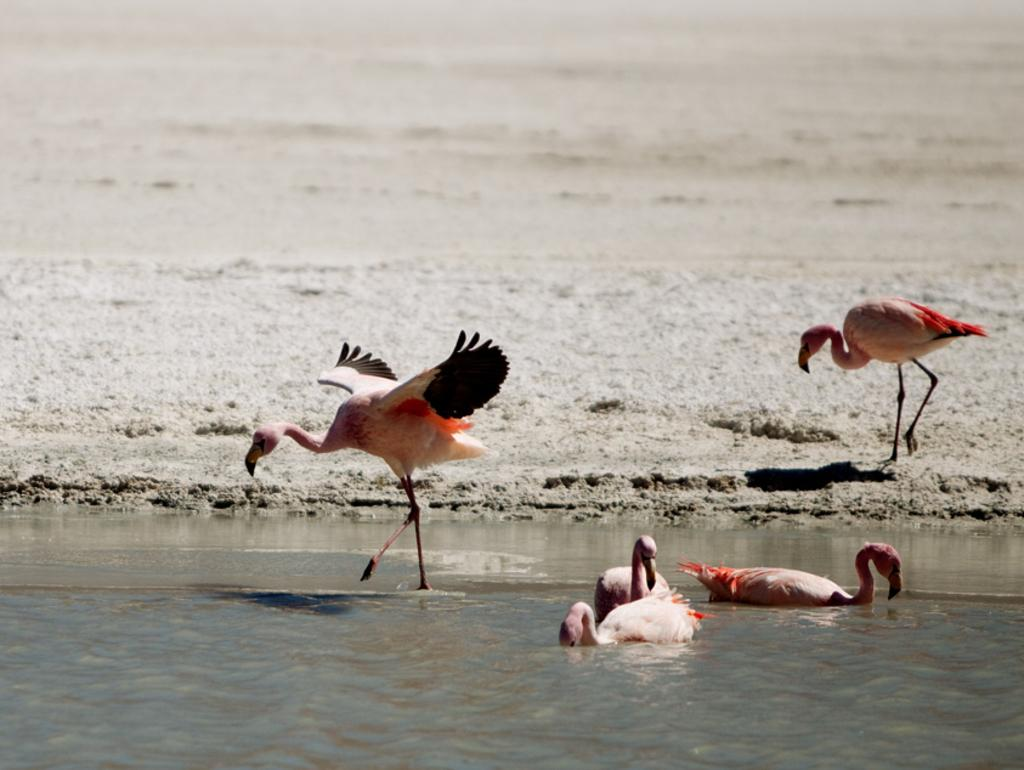What type of animals can be seen in the water in the image? There are birds in the water in the image. Can you describe the bird on the right side of the image? There is a bird standing on the land on the right side of the image. What type of fish can be seen swimming near the door in the image? There is no door present in the image, and no fish are visible. 